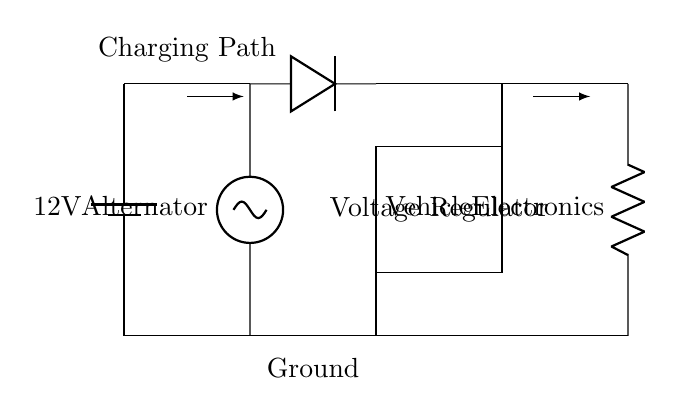What is the voltage of the car battery? The voltage is 12V, which is indicated by the battery label in the circuit diagram.
Answer: 12V What is the purpose of the diode in the circuit? The diode allows current to flow only in one direction, preventing reverse current from damaging the battery or other components.
Answer: Prevents reverse current What component regulates the voltage for the vehicle electronics? The voltage regulator is the component that maintains a consistent voltage level for the vehicle's electronic systems.
Answer: Voltage regulator How many main components are involved in this charging circuit? The circuit has four main components: a battery, an alternator, a voltage regulator, and a diode.
Answer: Four What is the direction of current flow in the charging path? The current flows from the alternator through the diode to the battery and then through the voltage regulator to the vehicle electronics.
Answer: Alternator to battery What kind of load is connected to the output of the voltage regulator? The load connected to the output is the vehicle electronics, which are represented by a resistor in the circuit diagram.
Answer: Vehicle electronics What happens to the voltage during the charging process? The voltage from the alternator is stepped down by the voltage regulator to a safe level before charging the battery and powering the vehicle electronics.
Answer: Stepped down 